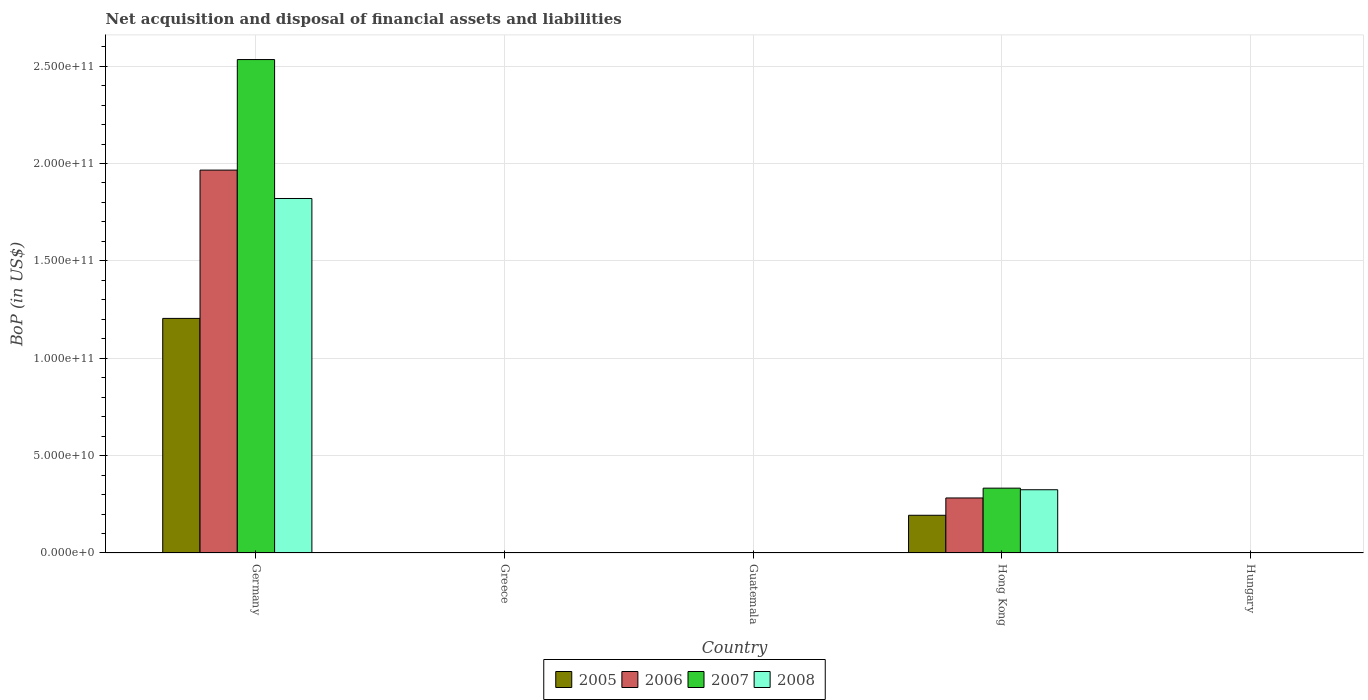How many different coloured bars are there?
Provide a short and direct response. 4. Are the number of bars on each tick of the X-axis equal?
Your response must be concise. No. How many bars are there on the 3rd tick from the left?
Your answer should be compact. 0. How many bars are there on the 5th tick from the right?
Keep it short and to the point. 4. What is the label of the 3rd group of bars from the left?
Your answer should be compact. Guatemala. What is the Balance of Payments in 2007 in Greece?
Make the answer very short. 0. Across all countries, what is the maximum Balance of Payments in 2008?
Your answer should be very brief. 1.82e+11. What is the total Balance of Payments in 2006 in the graph?
Make the answer very short. 2.25e+11. What is the difference between the Balance of Payments in 2006 in Greece and the Balance of Payments in 2005 in Guatemala?
Provide a short and direct response. 0. What is the average Balance of Payments in 2008 per country?
Make the answer very short. 4.29e+1. What is the difference between the Balance of Payments of/in 2008 and Balance of Payments of/in 2006 in Germany?
Keep it short and to the point. -1.46e+1. In how many countries, is the Balance of Payments in 2006 greater than 200000000000 US$?
Your answer should be compact. 0. What is the ratio of the Balance of Payments in 2006 in Germany to that in Hong Kong?
Your answer should be very brief. 6.96. What is the difference between the highest and the lowest Balance of Payments in 2007?
Your answer should be very brief. 2.53e+11. Is the sum of the Balance of Payments in 2005 in Germany and Hong Kong greater than the maximum Balance of Payments in 2008 across all countries?
Ensure brevity in your answer.  No. Is it the case that in every country, the sum of the Balance of Payments in 2008 and Balance of Payments in 2005 is greater than the sum of Balance of Payments in 2007 and Balance of Payments in 2006?
Your answer should be very brief. No. Is it the case that in every country, the sum of the Balance of Payments in 2006 and Balance of Payments in 2008 is greater than the Balance of Payments in 2007?
Provide a succinct answer. No. Are all the bars in the graph horizontal?
Give a very brief answer. No. How many countries are there in the graph?
Your answer should be very brief. 5. What is the difference between two consecutive major ticks on the Y-axis?
Keep it short and to the point. 5.00e+1. Are the values on the major ticks of Y-axis written in scientific E-notation?
Offer a very short reply. Yes. Does the graph contain any zero values?
Give a very brief answer. Yes. Does the graph contain grids?
Your response must be concise. Yes. How are the legend labels stacked?
Your answer should be compact. Horizontal. What is the title of the graph?
Your response must be concise. Net acquisition and disposal of financial assets and liabilities. What is the label or title of the X-axis?
Your answer should be compact. Country. What is the label or title of the Y-axis?
Provide a short and direct response. BoP (in US$). What is the BoP (in US$) in 2005 in Germany?
Keep it short and to the point. 1.20e+11. What is the BoP (in US$) in 2006 in Germany?
Make the answer very short. 1.97e+11. What is the BoP (in US$) in 2007 in Germany?
Make the answer very short. 2.53e+11. What is the BoP (in US$) of 2008 in Germany?
Keep it short and to the point. 1.82e+11. What is the BoP (in US$) in 2005 in Greece?
Make the answer very short. 0. What is the BoP (in US$) of 2005 in Guatemala?
Keep it short and to the point. 0. What is the BoP (in US$) in 2006 in Guatemala?
Your answer should be very brief. 0. What is the BoP (in US$) of 2007 in Guatemala?
Offer a very short reply. 0. What is the BoP (in US$) in 2005 in Hong Kong?
Your answer should be compact. 1.94e+1. What is the BoP (in US$) in 2006 in Hong Kong?
Ensure brevity in your answer.  2.83e+1. What is the BoP (in US$) in 2007 in Hong Kong?
Ensure brevity in your answer.  3.33e+1. What is the BoP (in US$) of 2008 in Hong Kong?
Your response must be concise. 3.25e+1. What is the BoP (in US$) of 2005 in Hungary?
Ensure brevity in your answer.  0. What is the BoP (in US$) in 2006 in Hungary?
Your response must be concise. 0. What is the BoP (in US$) of 2007 in Hungary?
Your answer should be very brief. 0. What is the BoP (in US$) in 2008 in Hungary?
Provide a short and direct response. 0. Across all countries, what is the maximum BoP (in US$) in 2005?
Ensure brevity in your answer.  1.20e+11. Across all countries, what is the maximum BoP (in US$) in 2006?
Your response must be concise. 1.97e+11. Across all countries, what is the maximum BoP (in US$) of 2007?
Provide a succinct answer. 2.53e+11. Across all countries, what is the maximum BoP (in US$) of 2008?
Keep it short and to the point. 1.82e+11. Across all countries, what is the minimum BoP (in US$) in 2005?
Offer a terse response. 0. Across all countries, what is the minimum BoP (in US$) of 2007?
Offer a terse response. 0. What is the total BoP (in US$) of 2005 in the graph?
Provide a short and direct response. 1.40e+11. What is the total BoP (in US$) of 2006 in the graph?
Your response must be concise. 2.25e+11. What is the total BoP (in US$) of 2007 in the graph?
Ensure brevity in your answer.  2.87e+11. What is the total BoP (in US$) in 2008 in the graph?
Provide a short and direct response. 2.15e+11. What is the difference between the BoP (in US$) in 2005 in Germany and that in Hong Kong?
Give a very brief answer. 1.01e+11. What is the difference between the BoP (in US$) of 2006 in Germany and that in Hong Kong?
Make the answer very short. 1.68e+11. What is the difference between the BoP (in US$) in 2007 in Germany and that in Hong Kong?
Your response must be concise. 2.20e+11. What is the difference between the BoP (in US$) of 2008 in Germany and that in Hong Kong?
Provide a succinct answer. 1.50e+11. What is the difference between the BoP (in US$) in 2005 in Germany and the BoP (in US$) in 2006 in Hong Kong?
Offer a very short reply. 9.22e+1. What is the difference between the BoP (in US$) of 2005 in Germany and the BoP (in US$) of 2007 in Hong Kong?
Give a very brief answer. 8.72e+1. What is the difference between the BoP (in US$) in 2005 in Germany and the BoP (in US$) in 2008 in Hong Kong?
Keep it short and to the point. 8.80e+1. What is the difference between the BoP (in US$) of 2006 in Germany and the BoP (in US$) of 2007 in Hong Kong?
Make the answer very short. 1.63e+11. What is the difference between the BoP (in US$) in 2006 in Germany and the BoP (in US$) in 2008 in Hong Kong?
Ensure brevity in your answer.  1.64e+11. What is the difference between the BoP (in US$) of 2007 in Germany and the BoP (in US$) of 2008 in Hong Kong?
Ensure brevity in your answer.  2.21e+11. What is the average BoP (in US$) in 2005 per country?
Keep it short and to the point. 2.80e+1. What is the average BoP (in US$) of 2006 per country?
Ensure brevity in your answer.  4.50e+1. What is the average BoP (in US$) of 2007 per country?
Your answer should be compact. 5.73e+1. What is the average BoP (in US$) of 2008 per country?
Provide a short and direct response. 4.29e+1. What is the difference between the BoP (in US$) of 2005 and BoP (in US$) of 2006 in Germany?
Give a very brief answer. -7.62e+1. What is the difference between the BoP (in US$) in 2005 and BoP (in US$) in 2007 in Germany?
Provide a short and direct response. -1.33e+11. What is the difference between the BoP (in US$) of 2005 and BoP (in US$) of 2008 in Germany?
Provide a short and direct response. -6.16e+1. What is the difference between the BoP (in US$) in 2006 and BoP (in US$) in 2007 in Germany?
Your answer should be compact. -5.68e+1. What is the difference between the BoP (in US$) in 2006 and BoP (in US$) in 2008 in Germany?
Provide a succinct answer. 1.46e+1. What is the difference between the BoP (in US$) of 2007 and BoP (in US$) of 2008 in Germany?
Offer a very short reply. 7.13e+1. What is the difference between the BoP (in US$) of 2005 and BoP (in US$) of 2006 in Hong Kong?
Ensure brevity in your answer.  -8.89e+09. What is the difference between the BoP (in US$) of 2005 and BoP (in US$) of 2007 in Hong Kong?
Provide a succinct answer. -1.39e+1. What is the difference between the BoP (in US$) in 2005 and BoP (in US$) in 2008 in Hong Kong?
Offer a very short reply. -1.31e+1. What is the difference between the BoP (in US$) in 2006 and BoP (in US$) in 2007 in Hong Kong?
Give a very brief answer. -5.04e+09. What is the difference between the BoP (in US$) of 2006 and BoP (in US$) of 2008 in Hong Kong?
Keep it short and to the point. -4.22e+09. What is the difference between the BoP (in US$) of 2007 and BoP (in US$) of 2008 in Hong Kong?
Offer a very short reply. 8.15e+08. What is the ratio of the BoP (in US$) of 2005 in Germany to that in Hong Kong?
Ensure brevity in your answer.  6.22. What is the ratio of the BoP (in US$) of 2006 in Germany to that in Hong Kong?
Offer a terse response. 6.96. What is the ratio of the BoP (in US$) in 2007 in Germany to that in Hong Kong?
Keep it short and to the point. 7.61. What is the ratio of the BoP (in US$) of 2008 in Germany to that in Hong Kong?
Keep it short and to the point. 5.61. What is the difference between the highest and the lowest BoP (in US$) in 2005?
Your answer should be very brief. 1.20e+11. What is the difference between the highest and the lowest BoP (in US$) of 2006?
Offer a terse response. 1.97e+11. What is the difference between the highest and the lowest BoP (in US$) in 2007?
Make the answer very short. 2.53e+11. What is the difference between the highest and the lowest BoP (in US$) of 2008?
Your answer should be very brief. 1.82e+11. 